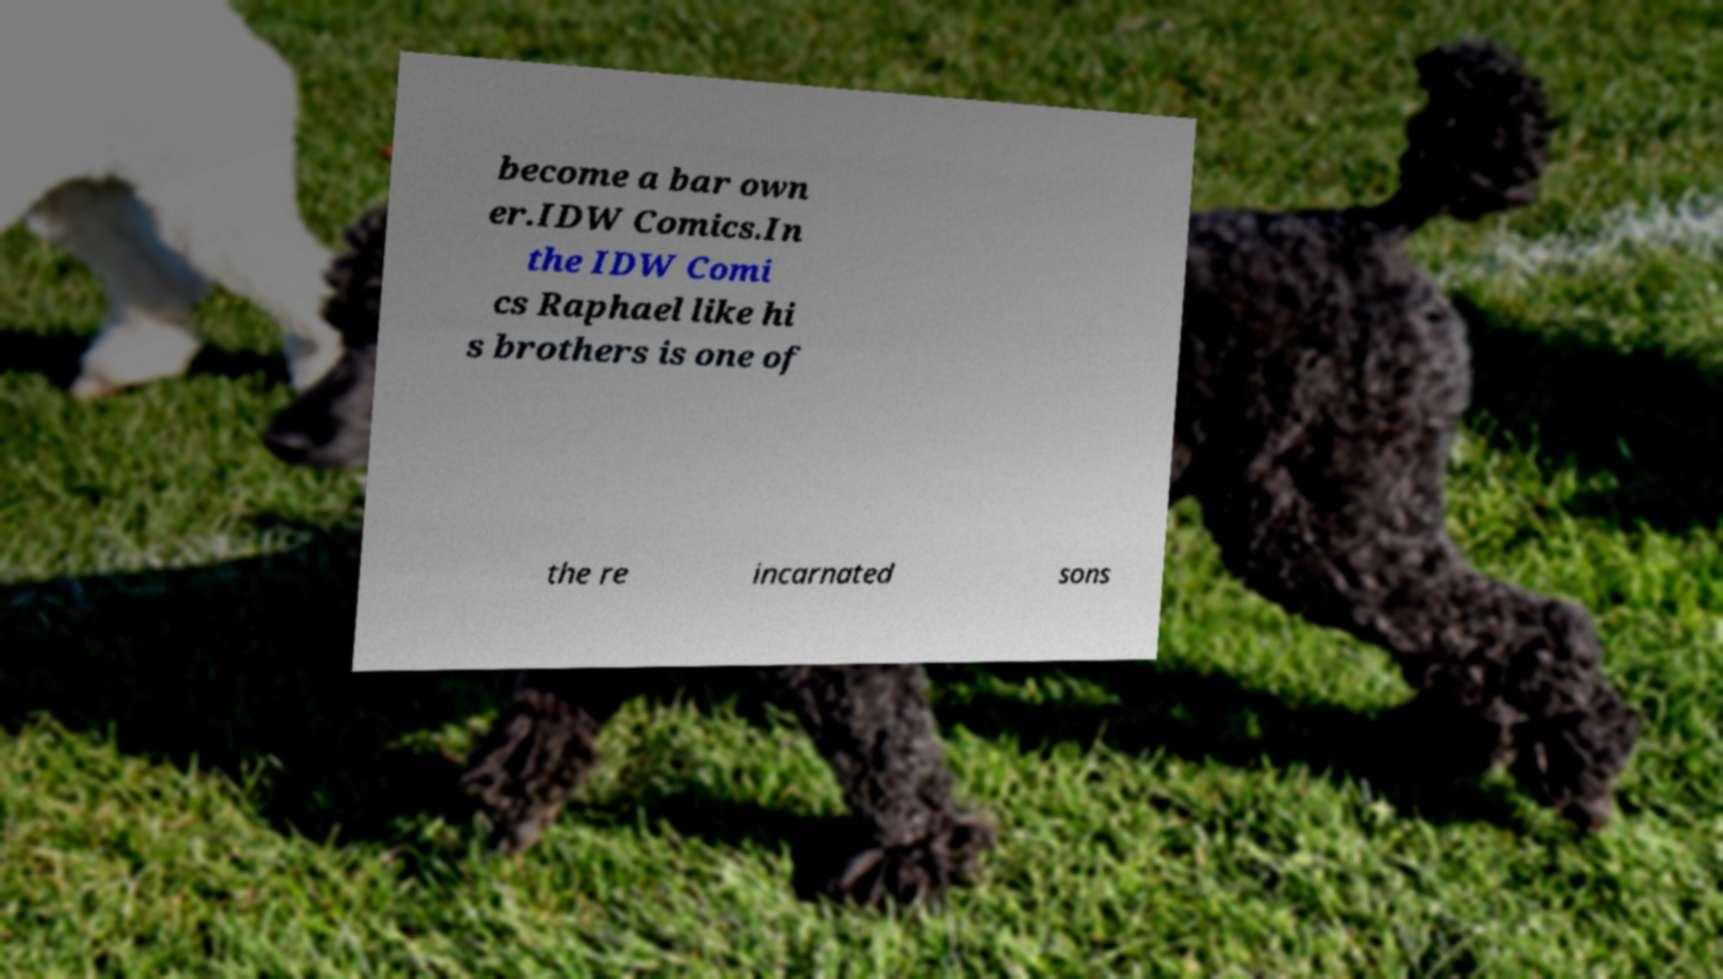Please read and relay the text visible in this image. What does it say? become a bar own er.IDW Comics.In the IDW Comi cs Raphael like hi s brothers is one of the re incarnated sons 